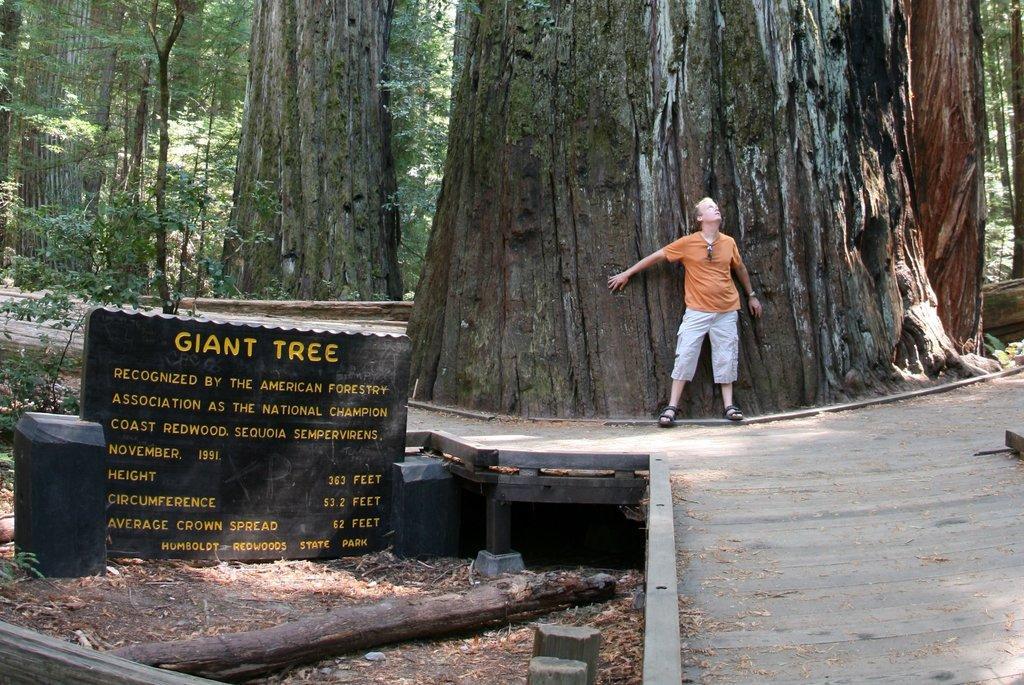Please provide a concise description of this image. In this image, we can see a person standing and in the background, there are trees and we can see a name board and there is a log and we can see a wood fence. At the bottom, there is road. 